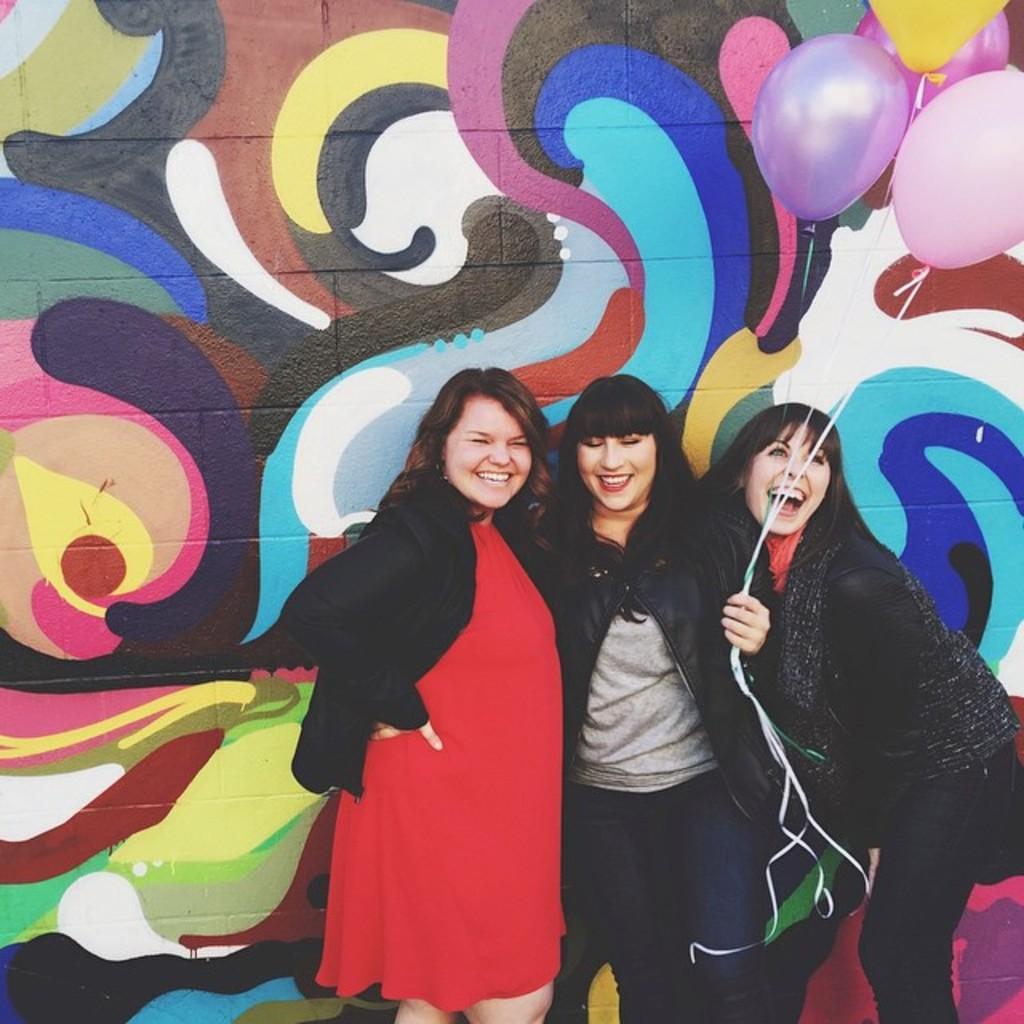Describe this image in one or two sentences. In this image we can see three persons. The person in the middle is holding the balloons. Behind the persons we can see a wall. On the wall we can see the painting. 